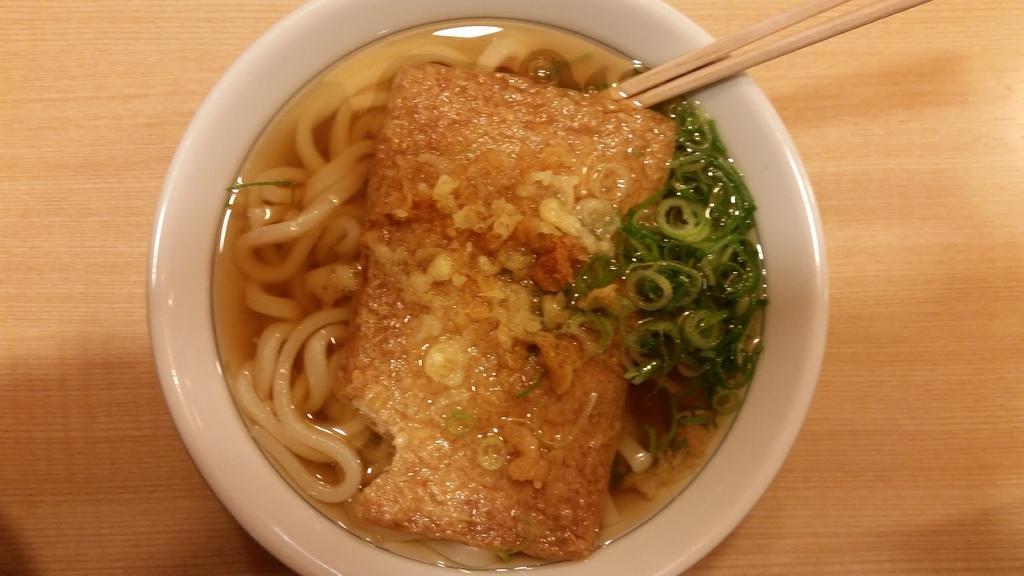In one or two sentences, can you explain what this image depicts? There is a liquid, noodles, vegetable pieces and sticks. These are in the bowl. The bowl is on the table. 